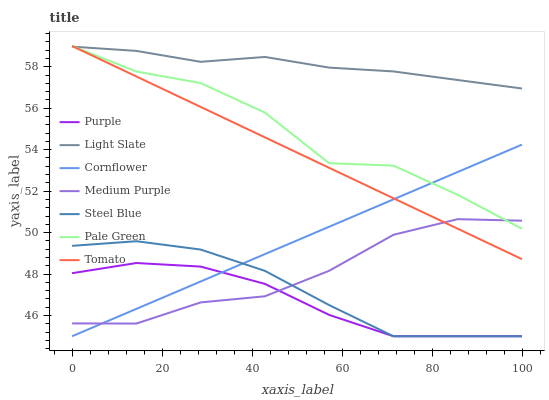Does Purple have the minimum area under the curve?
Answer yes or no. Yes. Does Light Slate have the maximum area under the curve?
Answer yes or no. Yes. Does Cornflower have the minimum area under the curve?
Answer yes or no. No. Does Cornflower have the maximum area under the curve?
Answer yes or no. No. Is Cornflower the smoothest?
Answer yes or no. Yes. Is Pale Green the roughest?
Answer yes or no. Yes. Is Purple the smoothest?
Answer yes or no. No. Is Purple the roughest?
Answer yes or no. No. Does Cornflower have the lowest value?
Answer yes or no. Yes. Does Medium Purple have the lowest value?
Answer yes or no. No. Does Pale Green have the highest value?
Answer yes or no. Yes. Does Cornflower have the highest value?
Answer yes or no. No. Is Purple less than Tomato?
Answer yes or no. Yes. Is Light Slate greater than Purple?
Answer yes or no. Yes. Does Tomato intersect Cornflower?
Answer yes or no. Yes. Is Tomato less than Cornflower?
Answer yes or no. No. Is Tomato greater than Cornflower?
Answer yes or no. No. Does Purple intersect Tomato?
Answer yes or no. No. 